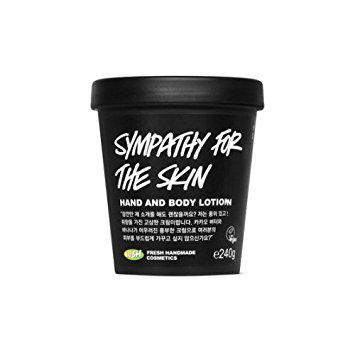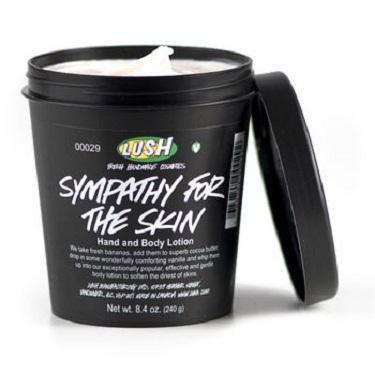The first image is the image on the left, the second image is the image on the right. Analyze the images presented: Is the assertion "In one image, the top is on the black tub, and in the other it is off, revealing a white cream inside" valid? Answer yes or no. Yes. The first image is the image on the left, the second image is the image on the right. Evaluate the accuracy of this statement regarding the images: "A lid is leaning next to one of the black tubs.". Is it true? Answer yes or no. Yes. 